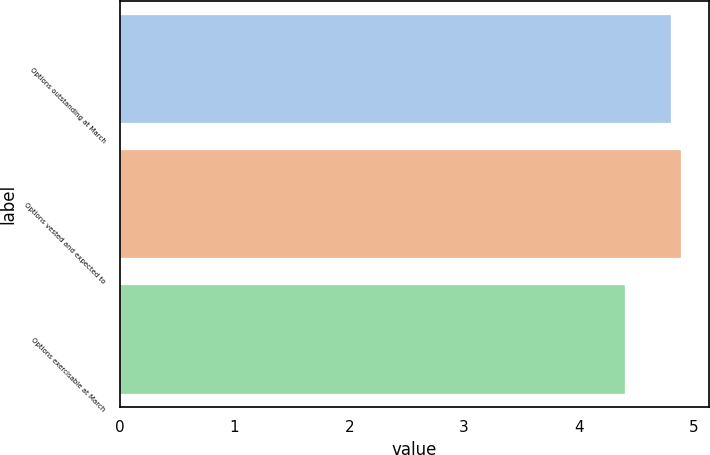Convert chart to OTSL. <chart><loc_0><loc_0><loc_500><loc_500><bar_chart><fcel>Options outstanding at March<fcel>Options vested and expected to<fcel>Options exercisable at March<nl><fcel>4.8<fcel>4.89<fcel>4.4<nl></chart> 